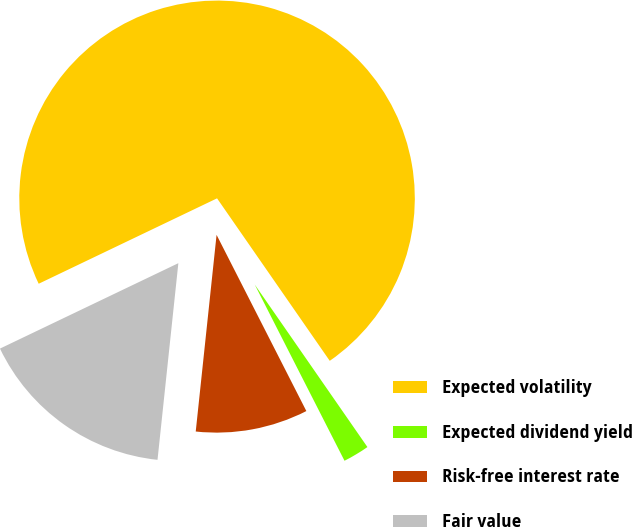Convert chart to OTSL. <chart><loc_0><loc_0><loc_500><loc_500><pie_chart><fcel>Expected volatility<fcel>Expected dividend yield<fcel>Risk-free interest rate<fcel>Fair value<nl><fcel>72.45%<fcel>2.15%<fcel>9.18%<fcel>16.21%<nl></chart> 